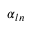Convert formula to latex. <formula><loc_0><loc_0><loc_500><loc_500>\alpha _ { \ln }</formula> 